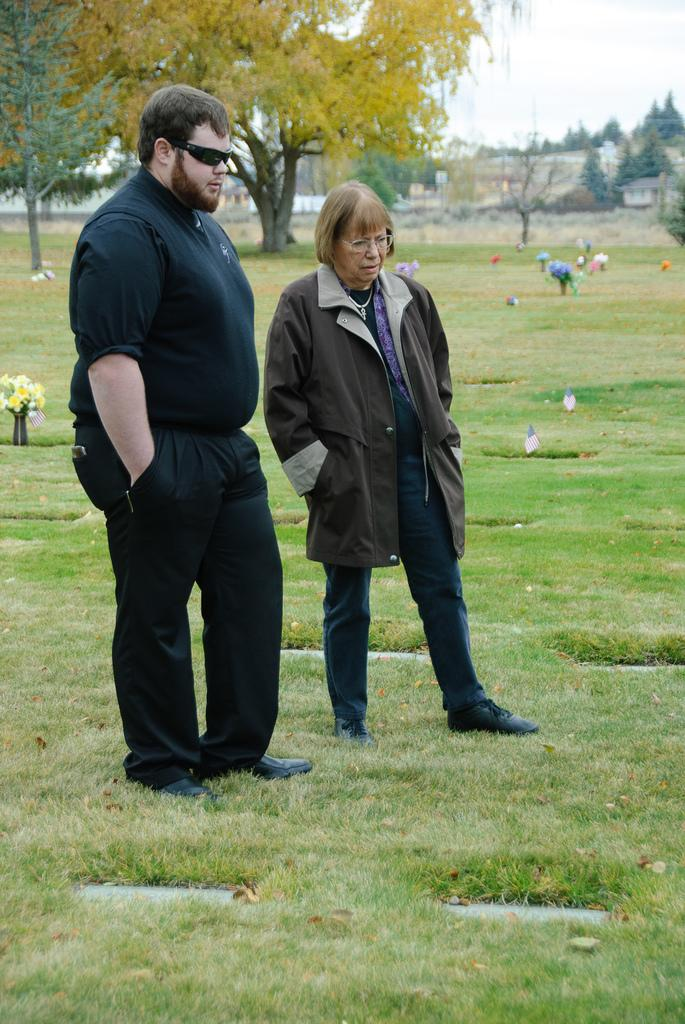How many people are in the image? There is a man and a woman in the image. What are the man and woman doing in the image? Both the man and woman are standing on the ground. What can be seen in the background of the image? There are trees, grass, the sky, and other unspecified objects visible in the background of the image. What is the chance of the alarm going off in the image? There is no alarm present in the image, so it is not possible to determine the chance of it going off. 